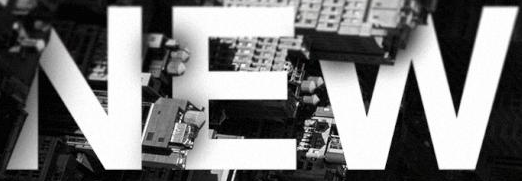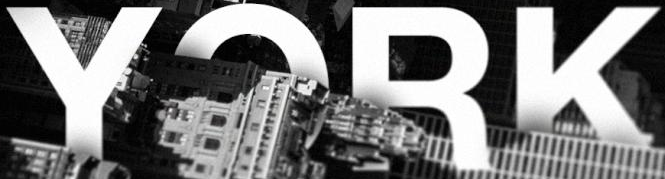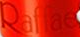What words are shown in these images in order, separated by a semicolon? NEW; YORK; Raffae 